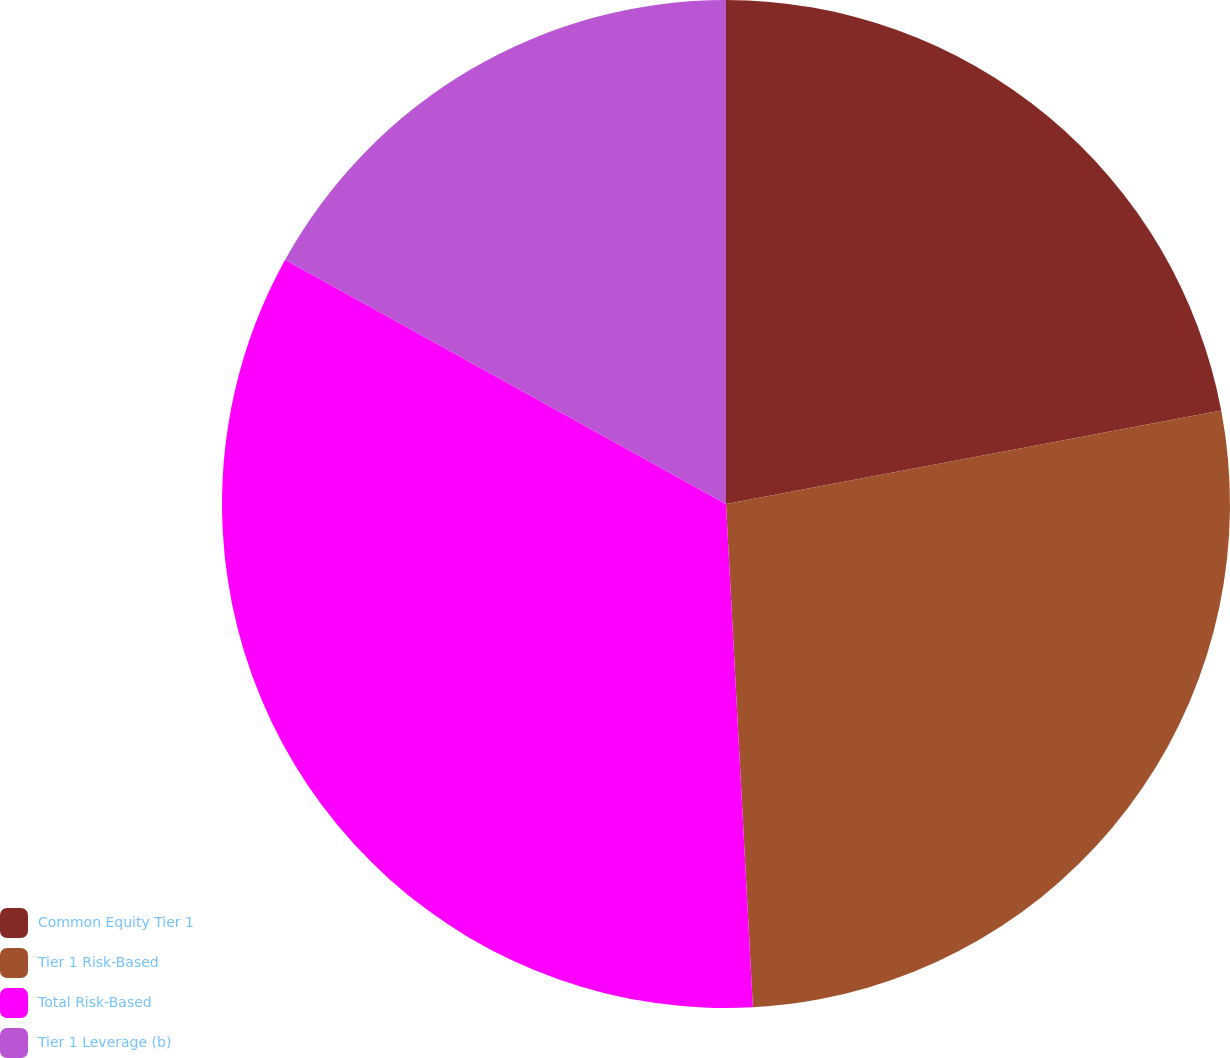Convert chart. <chart><loc_0><loc_0><loc_500><loc_500><pie_chart><fcel>Common Equity Tier 1<fcel>Tier 1 Risk-Based<fcel>Total Risk-Based<fcel>Tier 1 Leverage (b)<nl><fcel>22.03%<fcel>27.12%<fcel>33.9%<fcel>16.95%<nl></chart> 